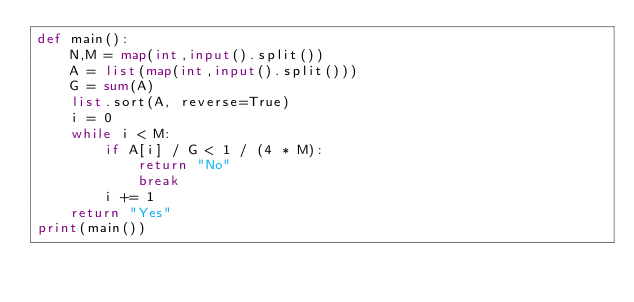<code> <loc_0><loc_0><loc_500><loc_500><_Python_>def main():
    N,M = map(int,input().split())
    A = list(map(int,input().split()))
    G = sum(A)
    list.sort(A, reverse=True)
    i = 0
    while i < M:
        if A[i] / G < 1 / (4 * M):
            return "No"
            break
        i += 1
    return "Yes"
print(main())</code> 